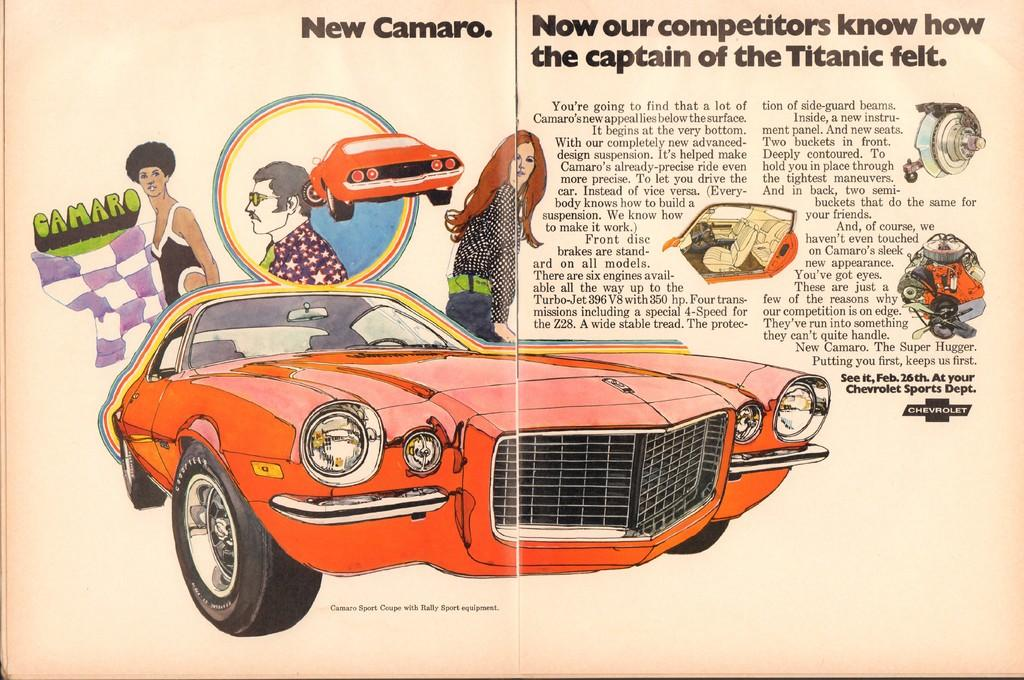What is present in the image that is related to writing or reading? There is a paper in the image that contains an image of cars and persons, as well as text. Can you describe the image depicted on the paper? The image on the paper contains cars and persons. What else can be found on the paper besides the image? There is text written on the paper. What type of show is being performed by the cars and persons in the image? There is no indication of a show being performed in the image; it simply contains an image of cars and persons. What sound does the horn make in the image? There is no horn present in the image, so it is not possible to determine the sound it might make. 